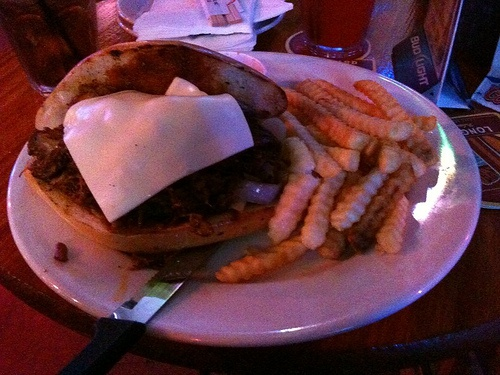Describe the objects in this image and their specific colors. I can see sandwich in black, maroon, brown, and lightpink tones, dining table in black, maroon, and brown tones, cup in black, maroon, and purple tones, knife in black, gray, and darkgray tones, and cup in black, maroon, purple, and navy tones in this image. 